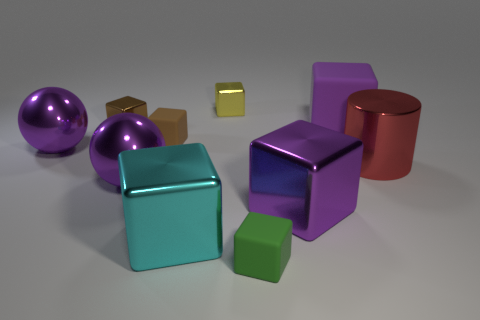Subtract all green rubber cubes. How many cubes are left? 6 Subtract all purple blocks. How many blocks are left? 5 Subtract all cubes. How many objects are left? 3 Subtract all cylinders. Subtract all tiny spheres. How many objects are left? 9 Add 8 large purple shiny blocks. How many large purple shiny blocks are left? 9 Add 5 small brown metallic cubes. How many small brown metallic cubes exist? 6 Subtract 0 gray cubes. How many objects are left? 10 Subtract 1 cylinders. How many cylinders are left? 0 Subtract all green cylinders. Subtract all brown spheres. How many cylinders are left? 1 Subtract all cyan spheres. How many purple cubes are left? 2 